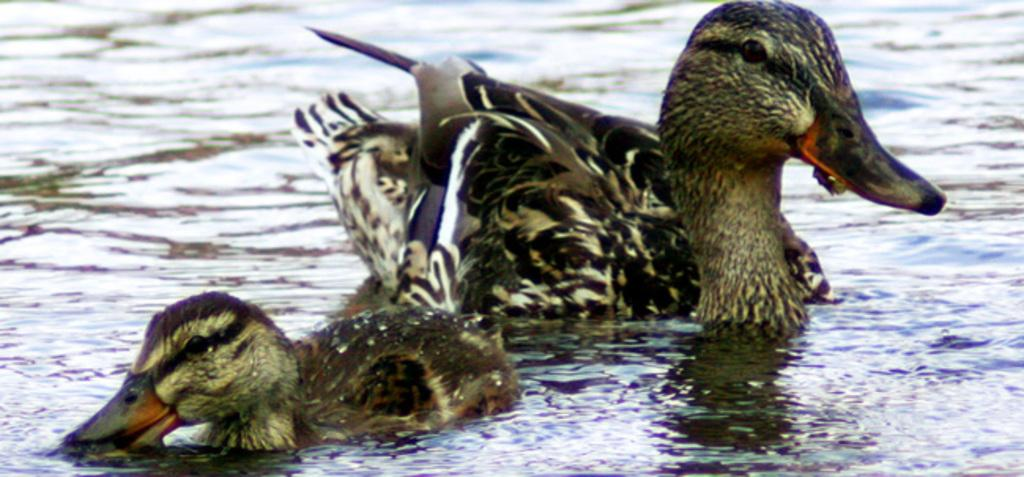What type of animals can be seen in the image? There are aquatic birds in the image. Where are the birds located in the image? The birds are in the water. What color are the cherries on the knee of the bird in the image? There are no cherries or knees present in the image, as it features aquatic birds in the water. 